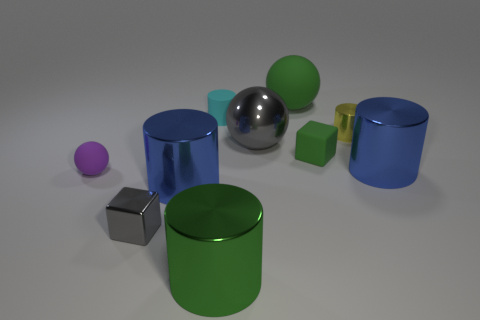What number of other objects are there of the same color as the small metallic cylinder? There are no other objects that share the exact color of the small metallic cylinder in the image. All other objects present have differing colors. 